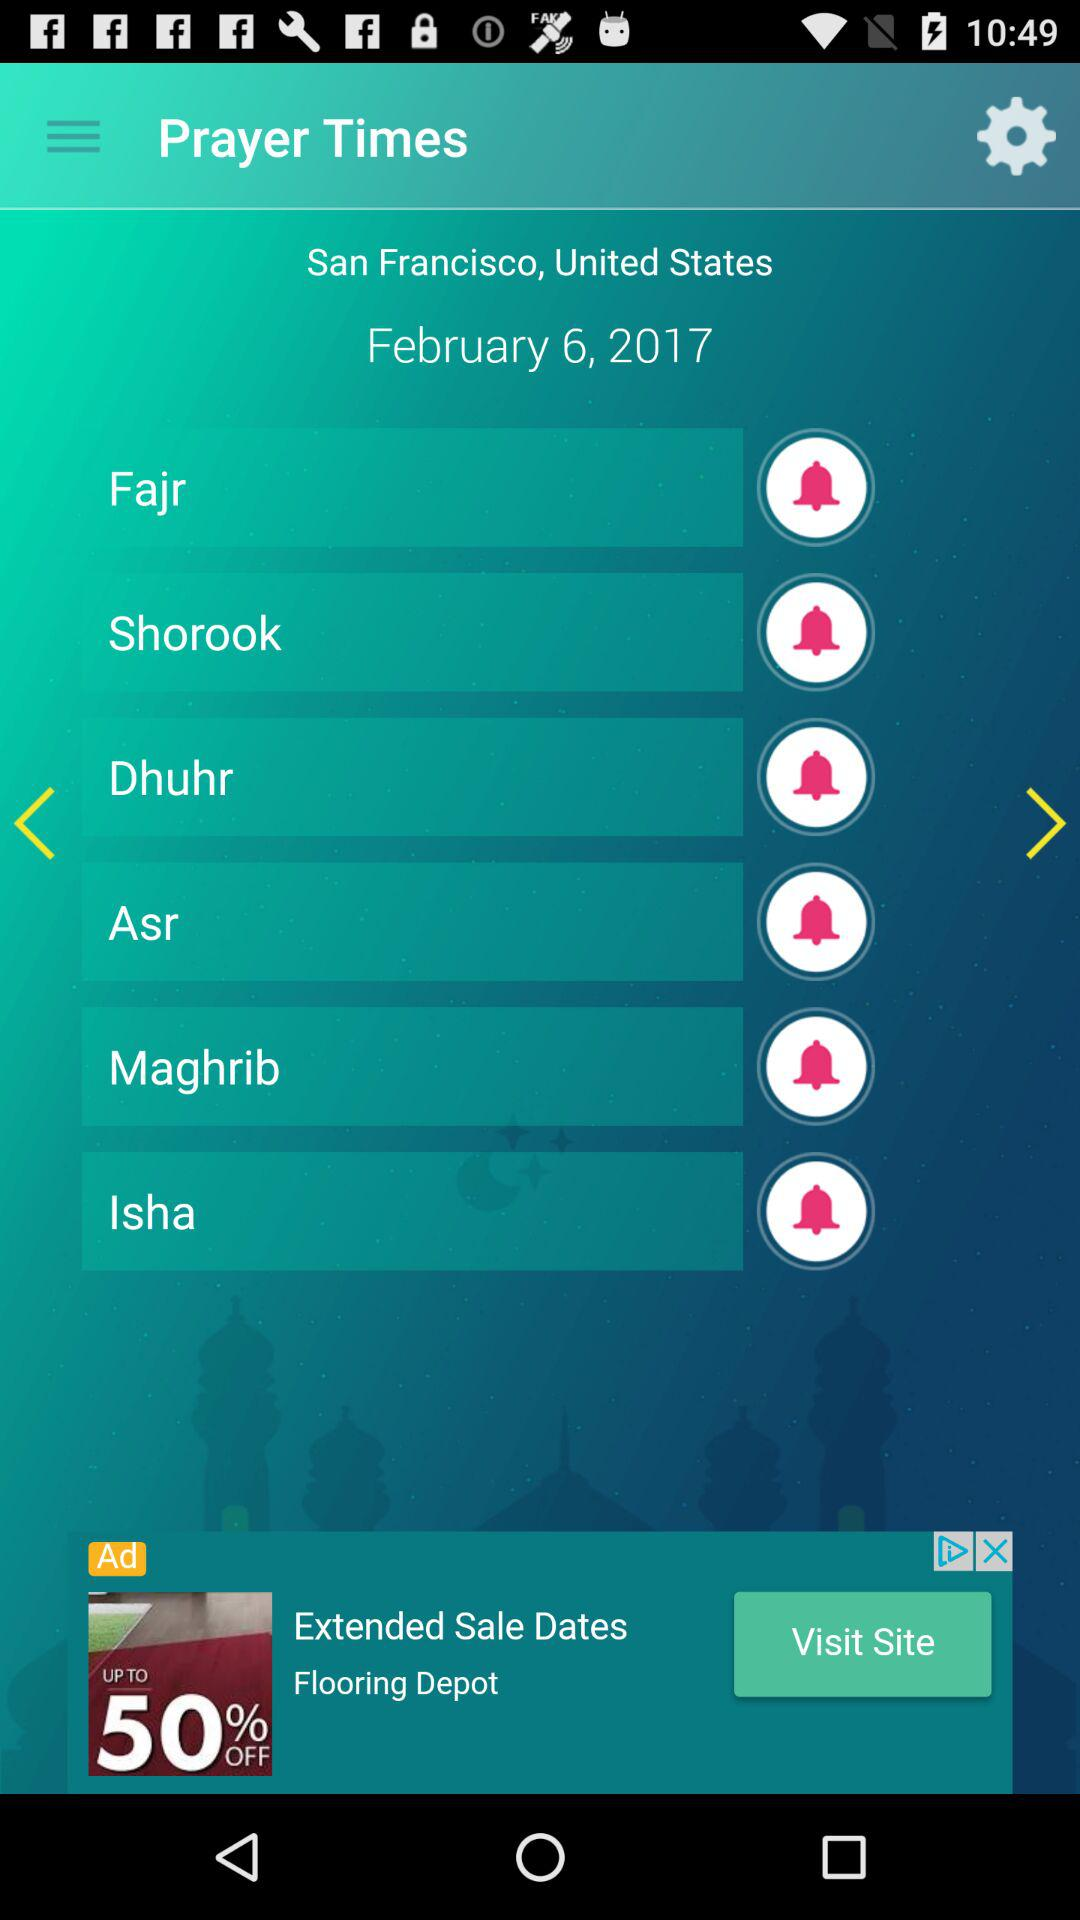What is the shown date? The shown date is February 6, 2017. 